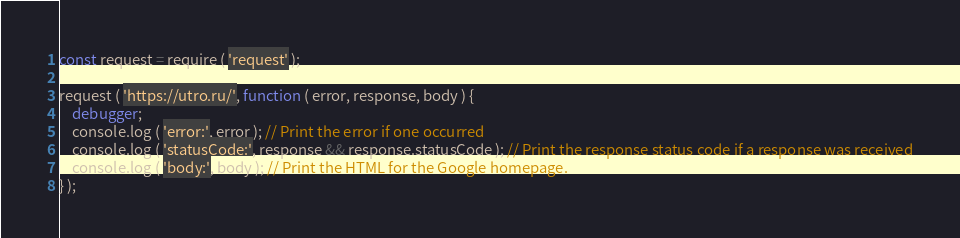Convert code to text. <code><loc_0><loc_0><loc_500><loc_500><_JavaScript_>const request = require ( 'request' );

request ( 'https://utro.ru/', function ( error, response, body ) {
    debugger;
    console.log ( 'error:', error ); // Print the error if one occurred
    console.log ( 'statusCode:', response && response.statusCode ); // Print the response status code if a response was received
    console.log ( 'body:', body ); // Print the HTML for the Google homepage.
} );</code> 